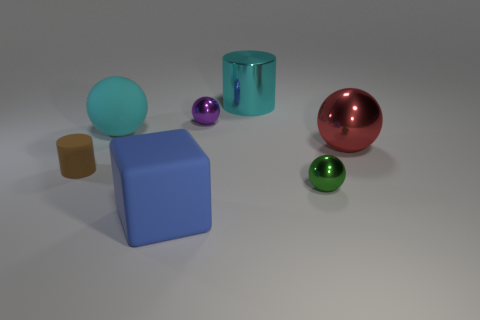Add 3 tiny gray objects. How many objects exist? 10 Subtract all blocks. How many objects are left? 6 Add 3 yellow things. How many yellow things exist? 3 Subtract 0 yellow spheres. How many objects are left? 7 Subtract all small blue rubber blocks. Subtract all large balls. How many objects are left? 5 Add 7 blocks. How many blocks are left? 8 